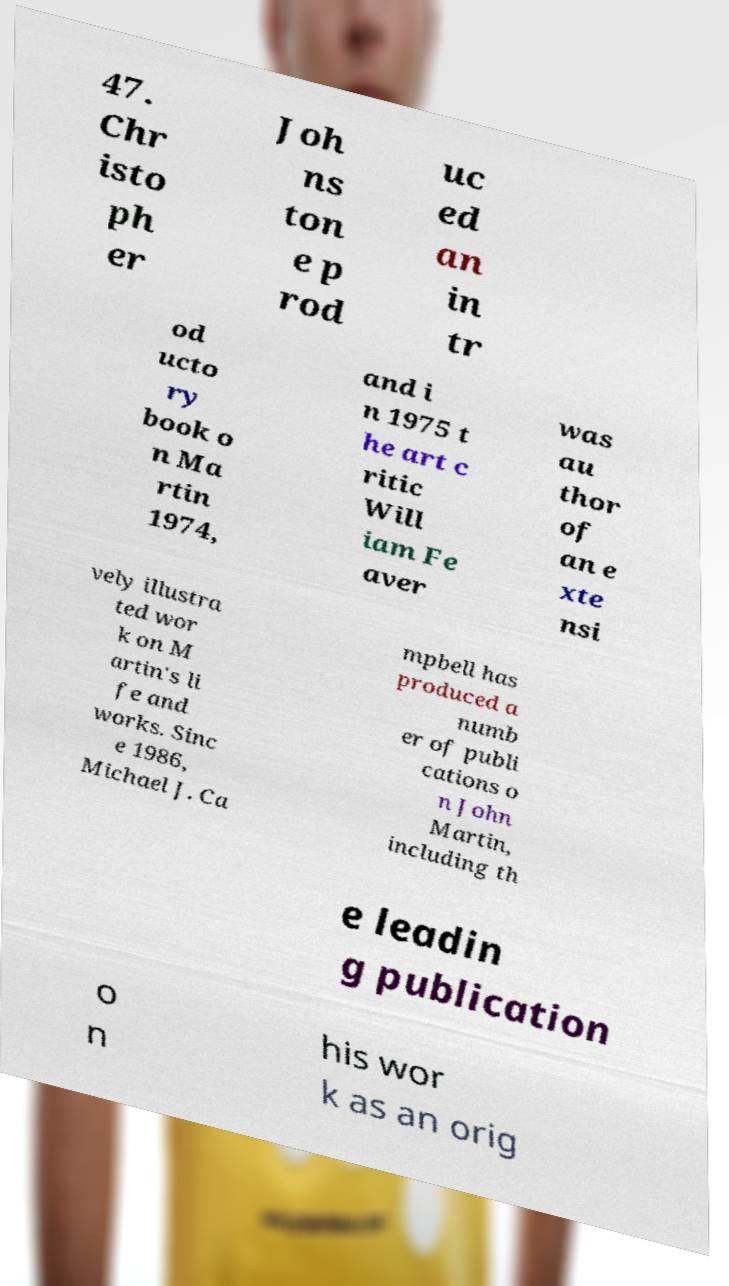I need the written content from this picture converted into text. Can you do that? 47. Chr isto ph er Joh ns ton e p rod uc ed an in tr od ucto ry book o n Ma rtin 1974, and i n 1975 t he art c ritic Will iam Fe aver was au thor of an e xte nsi vely illustra ted wor k on M artin's li fe and works. Sinc e 1986, Michael J. Ca mpbell has produced a numb er of publi cations o n John Martin, including th e leadin g publication o n his wor k as an orig 